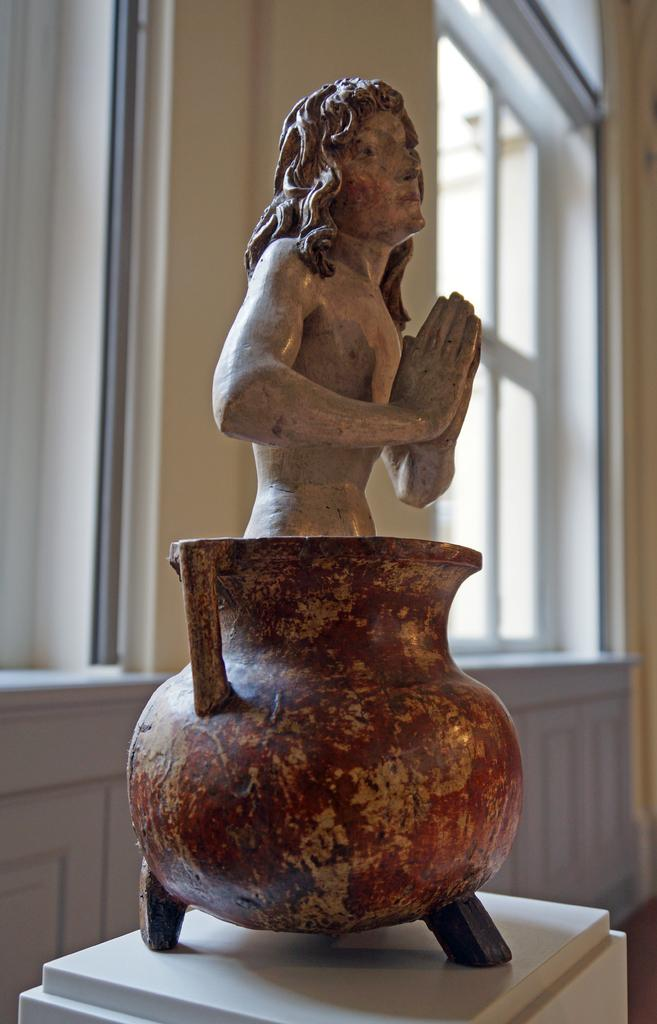What is the main subject of the image? There is a sculpture of a person in the image. What other objects can be seen in the image? There is a pot and a window in the image. Where is the hen located in the image? There is no hen present in the image. What type of food is being served in the lunchroom in the image? There is no lunchroom present in the image. 